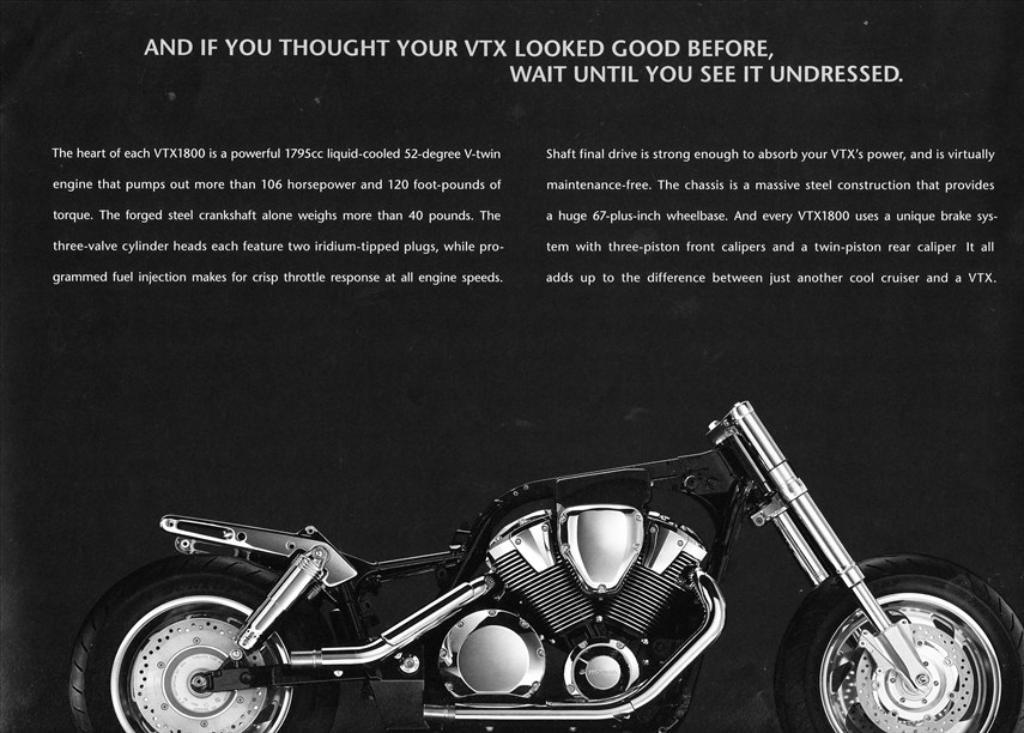What is the main subject of the image? The main subject of the image is a motorcycle. Where is the motorcycle located in the image? The motorcycle is at the bottom of the image. What can be seen at the top of the image? There is text written at the top of the image. What color is the background of the image? The background of the image is black. How many oranges are visible on the motorcycle in the image? There are no oranges present in the image. What type of cactus can be seen growing near the motorcycle in the image? There is no cactus present in the image; the background is black. 